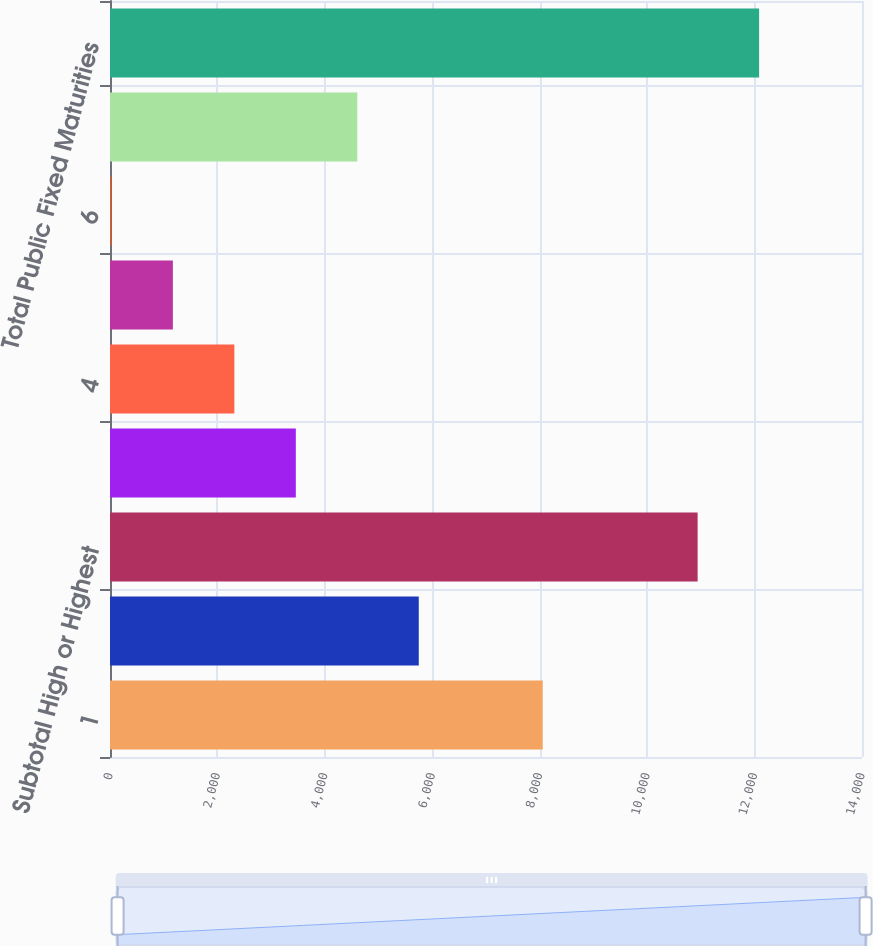Convert chart to OTSL. <chart><loc_0><loc_0><loc_500><loc_500><bar_chart><fcel>1<fcel>2<fcel>Subtotal High or Highest<fcel>3<fcel>4<fcel>5<fcel>6<fcel>Subtotal Other Securities<fcel>Total Public Fixed Maturities<nl><fcel>8056<fcel>5748.5<fcel>10940<fcel>3459.5<fcel>2315<fcel>1170.5<fcel>26<fcel>4604<fcel>12084.5<nl></chart> 